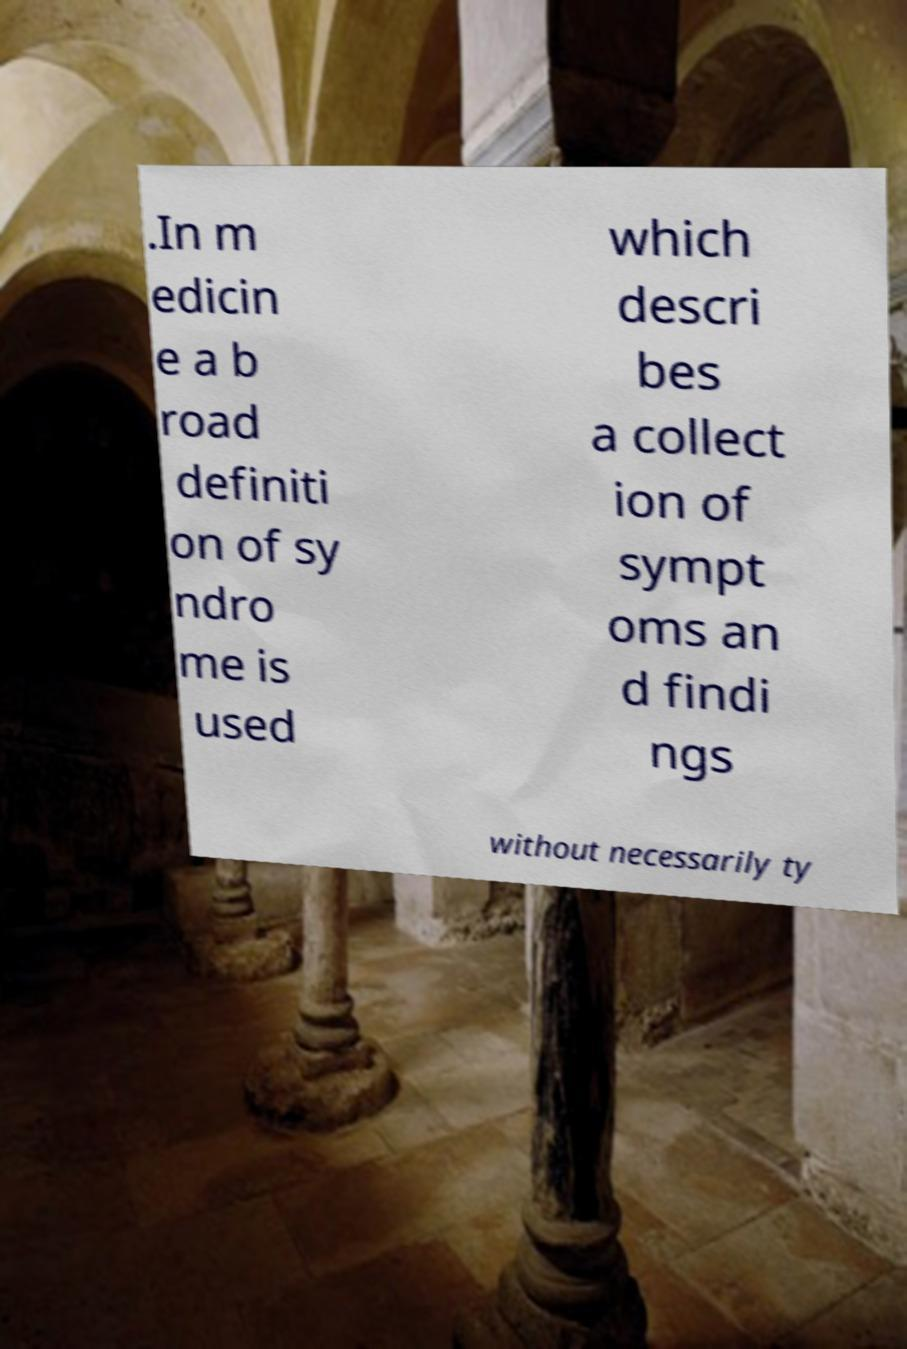Please read and relay the text visible in this image. What does it say? .In m edicin e a b road definiti on of sy ndro me is used which descri bes a collect ion of sympt oms an d findi ngs without necessarily ty 